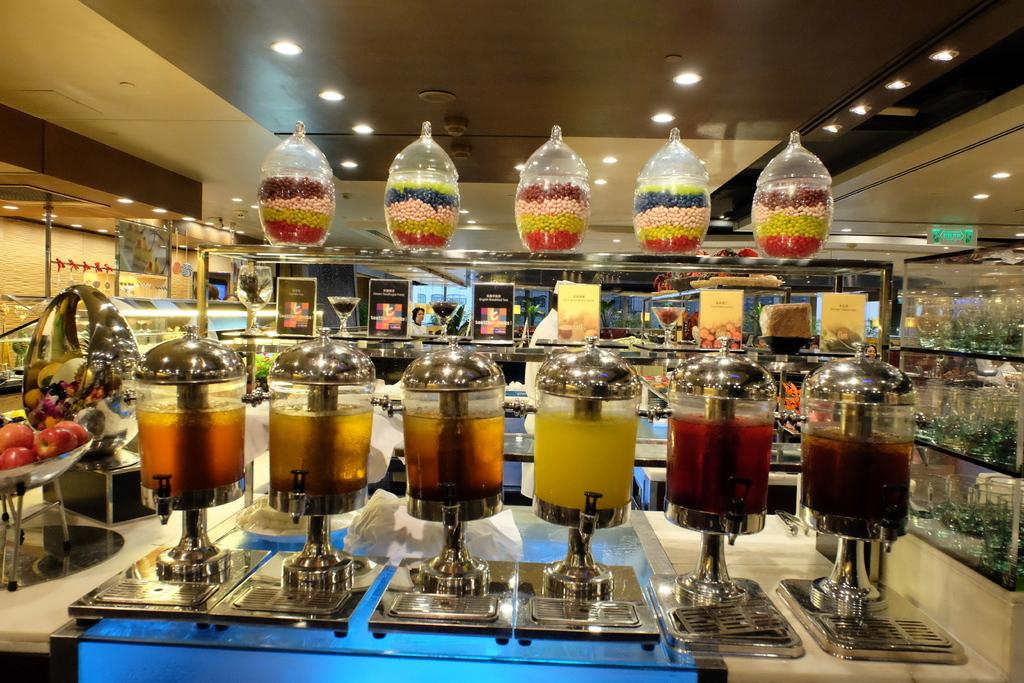What types of food items are in the jars and tins in the image? The jars contain juices, and the tins contain chocolates. What else can be seen beside the jars and tins in the image? There are other objects beside the jars and tins in the image. What is on the wall in the image? There are posters on the wall in the image. Can you see anyone writing on the wall in the image? There is no one writing on the wall in the image. Are there any wings visible in the image? There are no wings visible in the image. 